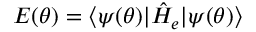Convert formula to latex. <formula><loc_0><loc_0><loc_500><loc_500>E ( \theta ) = \langle \psi ( \theta ) | \hat { H } _ { e } | \psi ( \theta ) \rangle</formula> 